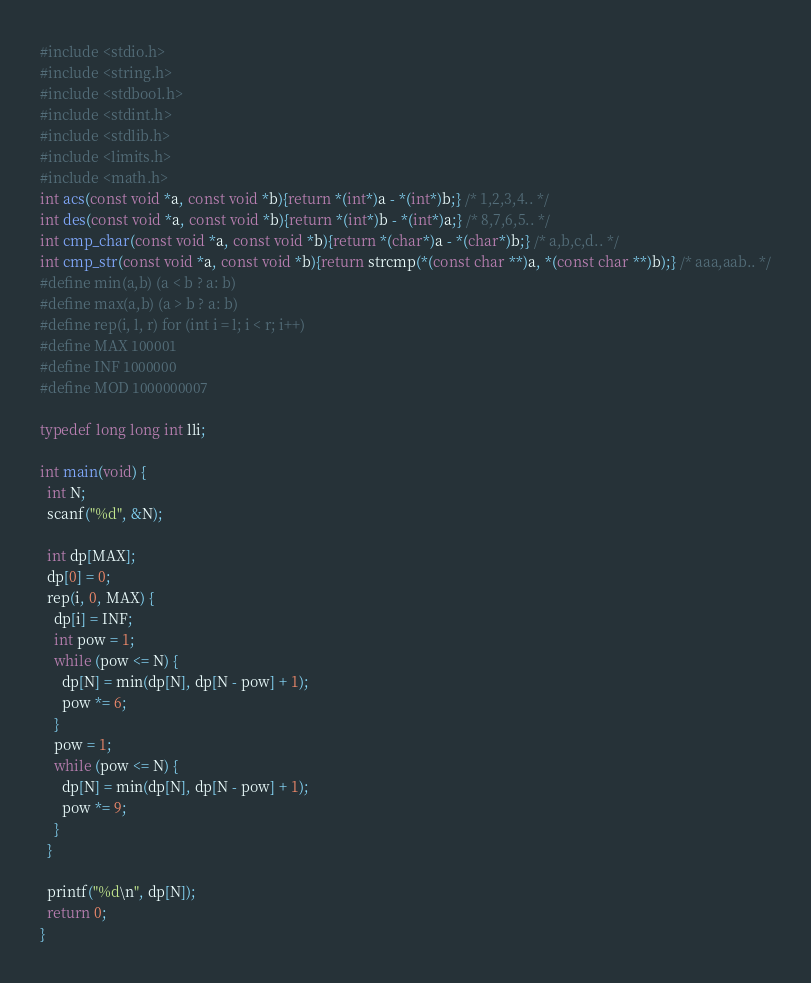Convert code to text. <code><loc_0><loc_0><loc_500><loc_500><_C_>#include <stdio.h>
#include <string.h>
#include <stdbool.h>
#include <stdint.h>
#include <stdlib.h>
#include <limits.h>
#include <math.h>
int acs(const void *a, const void *b){return *(int*)a - *(int*)b;} /* 1,2,3,4.. */
int des(const void *a, const void *b){return *(int*)b - *(int*)a;} /* 8,7,6,5.. */
int cmp_char(const void *a, const void *b){return *(char*)a - *(char*)b;} /* a,b,c,d.. */
int cmp_str(const void *a, const void *b){return strcmp(*(const char **)a, *(const char **)b);} /* aaa,aab.. */
#define min(a,b) (a < b ? a: b)
#define max(a,b) (a > b ? a: b)
#define rep(i, l, r) for (int i = l; i < r; i++)
#define MAX 100001
#define INF 1000000
#define MOD 1000000007

typedef long long int lli;

int main(void) {
  int N;
  scanf("%d", &N);

  int dp[MAX];
  dp[0] = 0;
  rep(i, 0, MAX) {
    dp[i] = INF;
    int pow = 1;
    while (pow <= N) {
      dp[N] = min(dp[N], dp[N - pow] + 1);
      pow *= 6;
    }
    pow = 1;
    while (pow <= N) {
      dp[N] = min(dp[N], dp[N - pow] + 1);
      pow *= 9;
    }
  }

  printf("%d\n", dp[N]);
  return 0;
}
</code> 